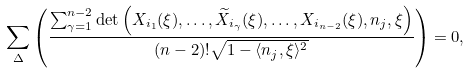Convert formula to latex. <formula><loc_0><loc_0><loc_500><loc_500>\sum _ { \Delta } \left ( \frac { \sum _ { \gamma = 1 } ^ { n - 2 } \det \left ( X _ { i _ { 1 } } ( \xi ) , \dots , \widetilde { X } _ { i _ { \gamma } } ( \xi ) , \dots , X _ { i _ { n - 2 } } ( \xi ) , n _ { j } , \xi \right ) } { ( n - 2 ) ! \sqrt { 1 - \langle n _ { j } , \xi \rangle ^ { 2 } } } \right ) = 0 ,</formula> 